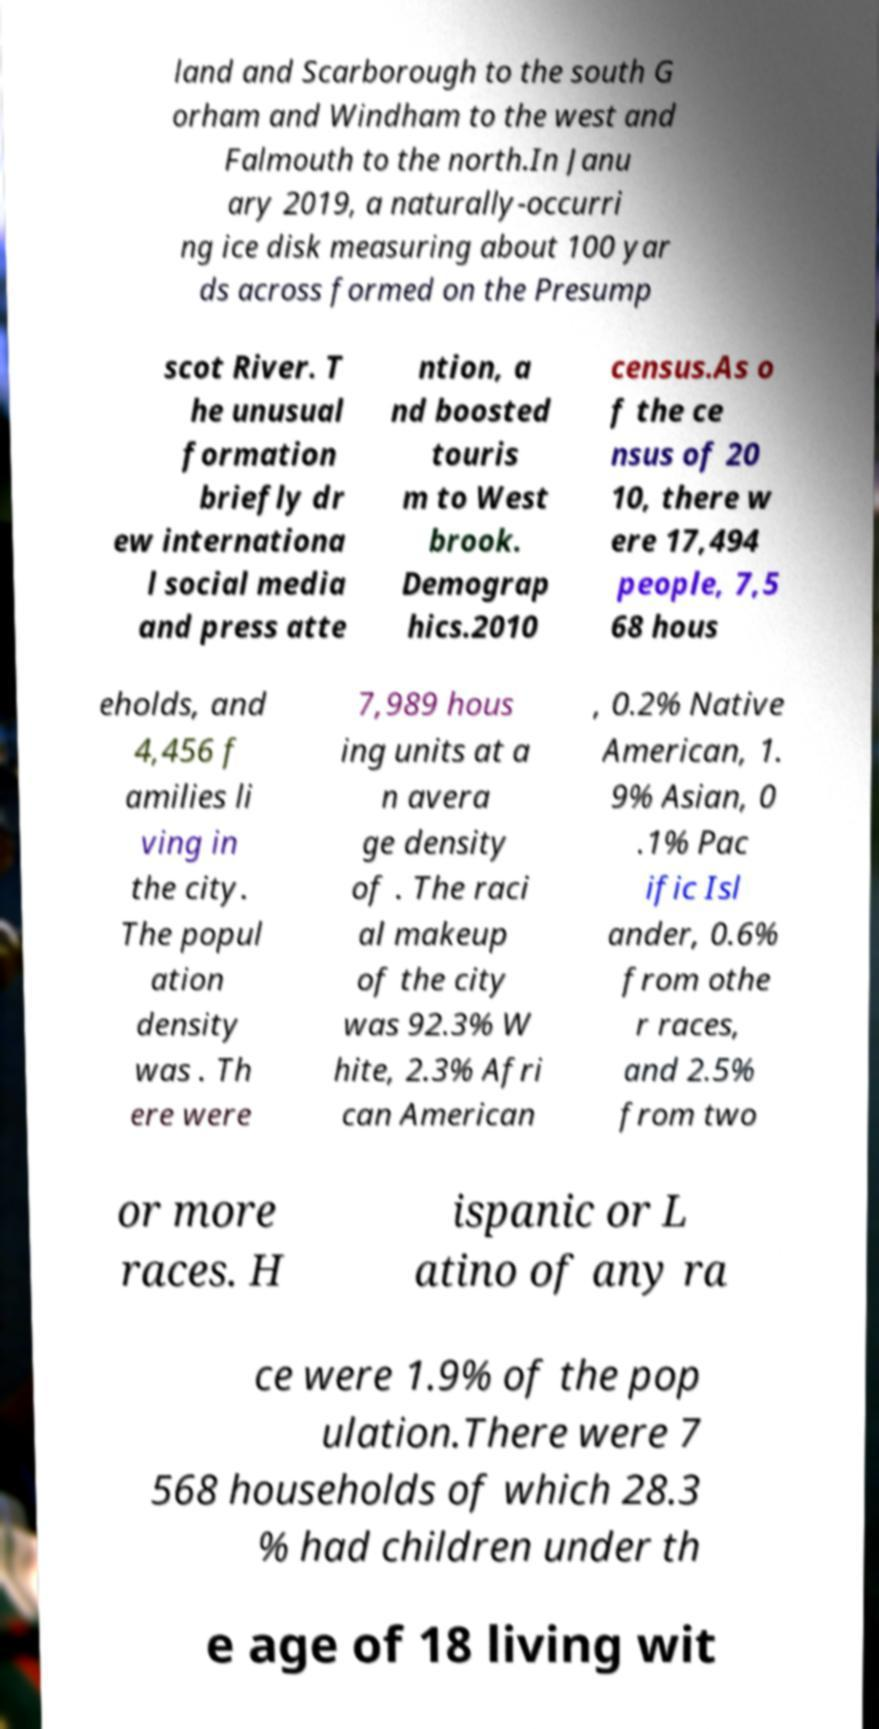What messages or text are displayed in this image? I need them in a readable, typed format. land and Scarborough to the south G orham and Windham to the west and Falmouth to the north.In Janu ary 2019, a naturally-occurri ng ice disk measuring about 100 yar ds across formed on the Presump scot River. T he unusual formation briefly dr ew internationa l social media and press atte ntion, a nd boosted touris m to West brook. Demograp hics.2010 census.As o f the ce nsus of 20 10, there w ere 17,494 people, 7,5 68 hous eholds, and 4,456 f amilies li ving in the city. The popul ation density was . Th ere were 7,989 hous ing units at a n avera ge density of . The raci al makeup of the city was 92.3% W hite, 2.3% Afri can American , 0.2% Native American, 1. 9% Asian, 0 .1% Pac ific Isl ander, 0.6% from othe r races, and 2.5% from two or more races. H ispanic or L atino of any ra ce were 1.9% of the pop ulation.There were 7 568 households of which 28.3 % had children under th e age of 18 living wit 